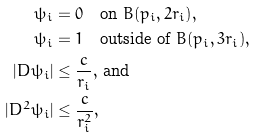<formula> <loc_0><loc_0><loc_500><loc_500>\psi _ { i } & = 0 \quad \text {on $B(p_{i},2r_{i})$} , \\ \psi _ { i } & = 1 \quad \text {outside of $B(p_{i},3r_{i})$} , \\ | D \psi _ { i } | & \leq \frac { c } { r _ { i } } , \, \text {and} \\ | D ^ { 2 } \psi _ { i } | & \leq \frac { c } { r _ { i } ^ { 2 } } ,</formula> 